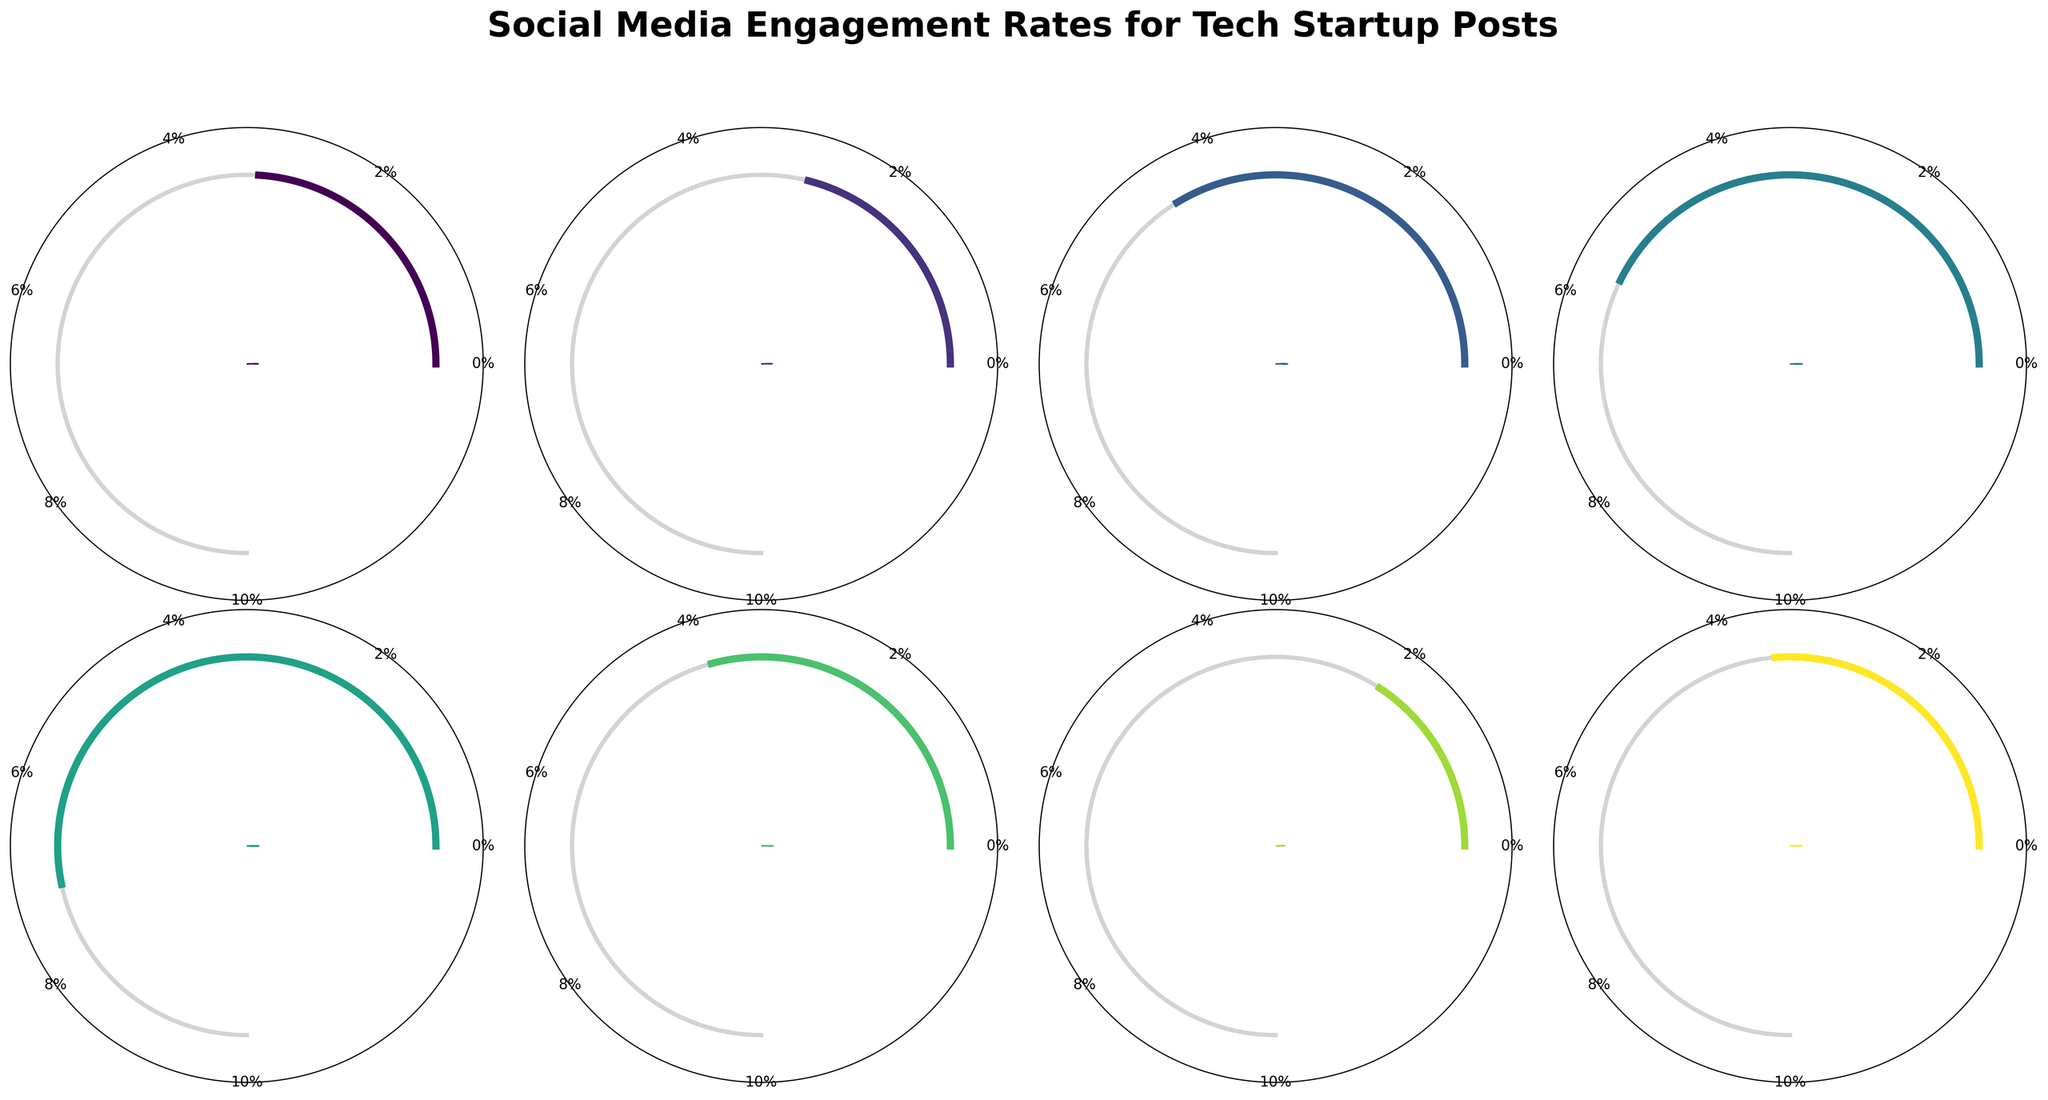What's the highest engagement rate shown in the gauge charts, and on which platform is it? The highest engagement rate can be identified by looking at the gauge that shows the highest percentage. TikTok has an engagement rate of 7.1%, which is higher than the rates shown for all other platforms.
Answer: 7.1%, TikTok What's the engagement rate for the platform 'Instagram'? Locate the gauge chart labeled 'Instagram'. The percentage shown on this gauge is the engagement rate for the platform, which is 5.7%.
Answer: 5.7% How does the engagement rate of LinkedIn compare to YouTube? To compare, observe the gauges for LinkedIn and YouTube. LinkedIn has an engagement rate of 4.5%, and YouTube has an engagement rate of 3.9%. LinkedIn's rate is higher.
Answer: LinkedIn is higher What's the total engagement rate if you sum Facebook and Twitter's rates? Find and add the engagement rates for Facebook (3.2%) and Twitter (2.8%). The total is 3.2% + 2.8% = 6.0%.
Answer: 6.0% Which platform has a lower engagement rate: Medium or Reddit? Compare the gauge charts for Medium and Reddit. Medium has an engagement rate of 2.1%, and Reddit has an engagement rate of 3.5%. Medium's rate is lower.
Answer: Medium Average the engagement rates of Instagram, TikTok, and YouTube. What is the average rate? Add the engagement rates of Instagram (5.7%), TikTok (7.1%), and YouTube (3.9%) and divide by 3. (5.7 + 7.1 + 3.9) / 3 = 16.7 / 3 ≈ 5.57%
Answer: 5.57% What's the difference between the highest and lowest engagement rates? Identify the highest rate (TikTok at 7.1%) and the lowest rate (Medium at 2.1%). The difference is 7.1% - 2.1%, which equals 5.0%.
Answer: 5.0% What percentage of the maximum rate is Instagram's engagement rate? The maximum rate is set to 10%. Instagram's rate is 5.7%. Calculate (5.7 / 10) * 100 to get 57%.
Answer: 57% On which platform is the engagement rate closest to 4%? Look for the platform with an engagement rate nearest to 4%. YouTube has a rate of 3.9%, which is closest to 4%.
Answer: YouTube What's the median engagement rate of all the platforms? List the engagement rates: 2.1, 2.8, 3.2, 3.5, 3.9, 4.5, 5.7, 7.1. The median is the average of the two middle numbers (3.5 and 3.9). (3.5 + 3.9) / 2 = 3.7
Answer: 3.7 